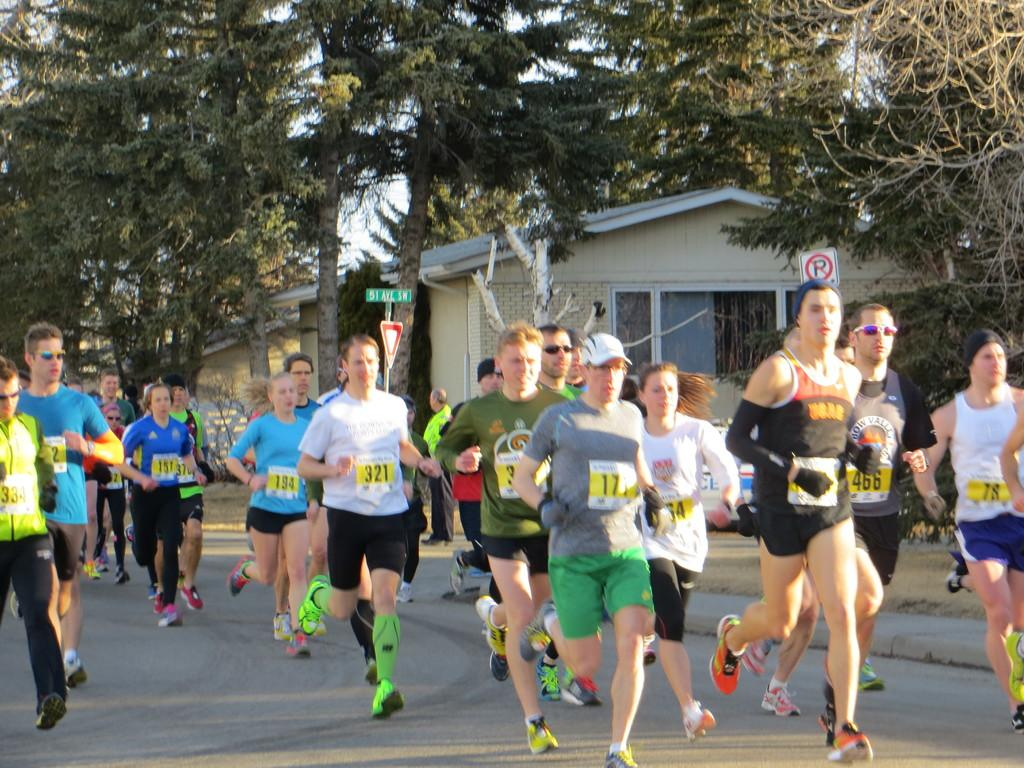What are the people in the image doing? The people in the image are running on the road. What can be seen in the background of the image? There are trees visible in the image. What is present on the sidewalk in the image? There are sign boards on the sidewalk in the image. What type of structures can be seen in the image? There are houses in the image. Can you tell me how many monkeys are sitting on the sign boards in the image? There are no monkeys present in the image; it features people running on the road, trees, sign boards, and houses. 